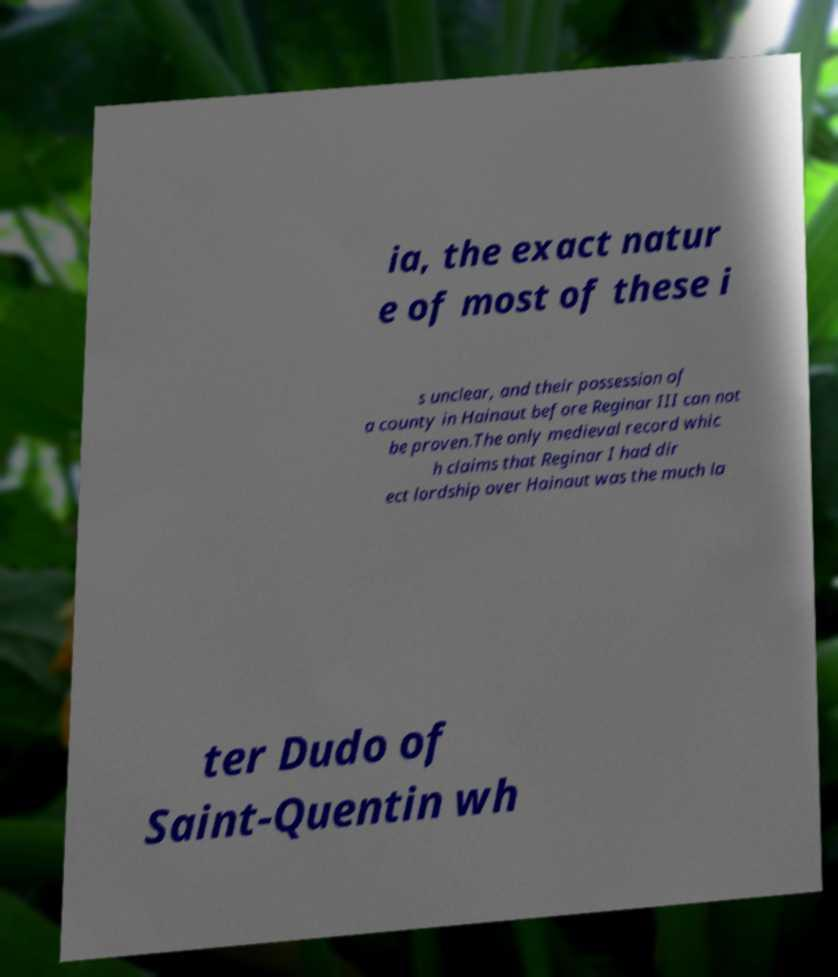Can you accurately transcribe the text from the provided image for me? ia, the exact natur e of most of these i s unclear, and their possession of a county in Hainaut before Reginar III can not be proven.The only medieval record whic h claims that Reginar I had dir ect lordship over Hainaut was the much la ter Dudo of Saint-Quentin wh 